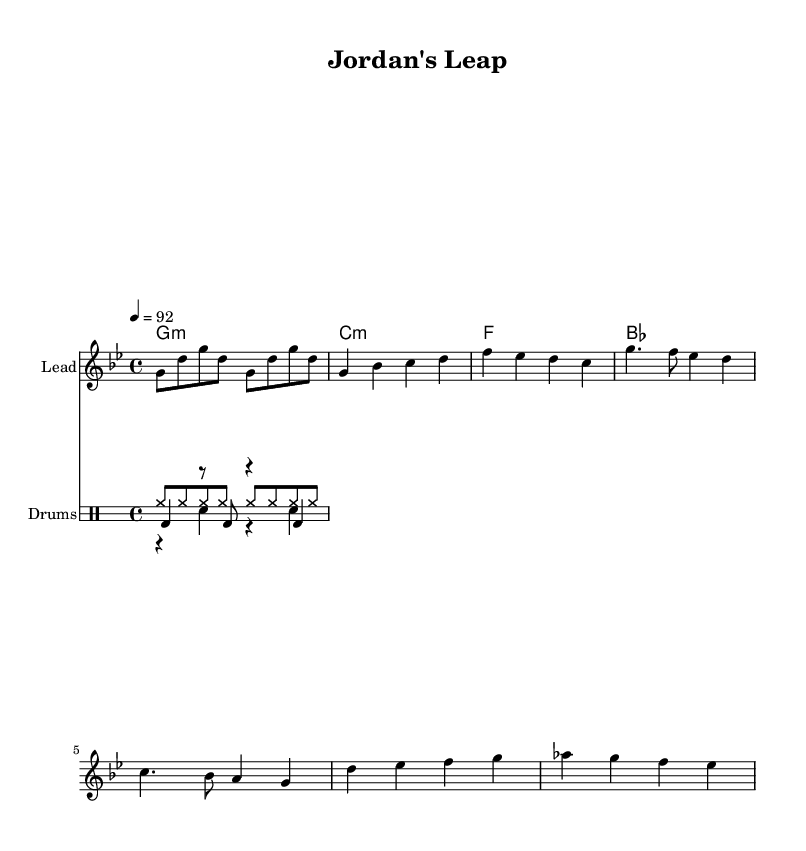What is the key signature of this music? The key signature is G minor, which has two flats (B flat and E flat) and is indicated at the beginning of the score.
Answer: G minor What is the time signature of the piece? The time signature is 4/4, which means there are four beats in each measure and the quarter note receives one beat; this is indicated at the beginning of the score.
Answer: 4/4 What is the tempo marking for this music? The tempo marking is 92 beats per minute, as indicated in the tempo section at the beginning of the score.
Answer: 92 How many distinct sections are present in the melody? There are four distinct sections in the melody: Intro, Verse, Chorus, and Bridge, as indicated by the labeled parts in the score.
Answer: Four What is the primary emotional theme conveyed in the lyrics? The primary emotional theme revolves around overcoming obstacles and achieving greatness, typical in motivational rap, which aligns with the title "Jordan's Leap."
Answer: Overcoming obstacles What type of drum pattern is predominantly used in the rhythm section? The predominant drum pattern comprises a kick drum, snare, and hi-hat, which are classic elements of hip-hop music, providing a strong rhythmic foundation.
Answer: Kick, snare, hi-hat Which phrase in the melody serves as the main hook of the song? The main hook of the song is found in the melody of the chorus, characterized by its memorable and repetitive nature, designed to be catchy and uplifting.
Answer: Chorus 